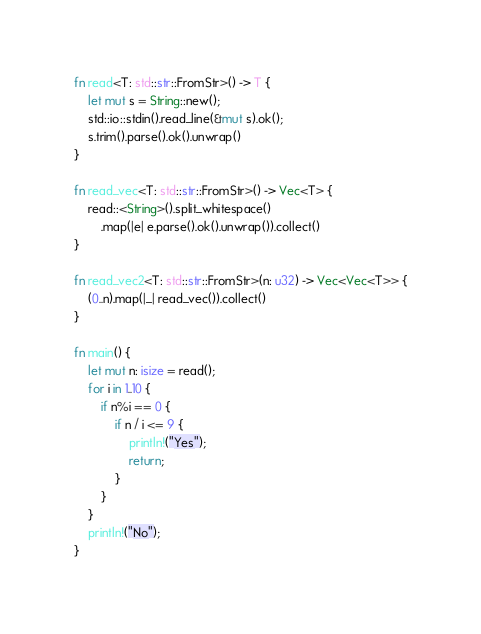<code> <loc_0><loc_0><loc_500><loc_500><_Rust_>fn read<T: std::str::FromStr>() -> T {
    let mut s = String::new();
    std::io::stdin().read_line(&mut s).ok();
    s.trim().parse().ok().unwrap()
}

fn read_vec<T: std::str::FromStr>() -> Vec<T> {
    read::<String>().split_whitespace()
        .map(|e| e.parse().ok().unwrap()).collect()
}

fn read_vec2<T: std::str::FromStr>(n: u32) -> Vec<Vec<T>> {
    (0..n).map(|_| read_vec()).collect()
}

fn main() {
    let mut n: isize = read();
    for i in 1..10 {
        if n%i == 0 {
            if n / i <= 9 {
                println!("Yes");
                return;
            }
        }
    }
    println!("No");
}</code> 